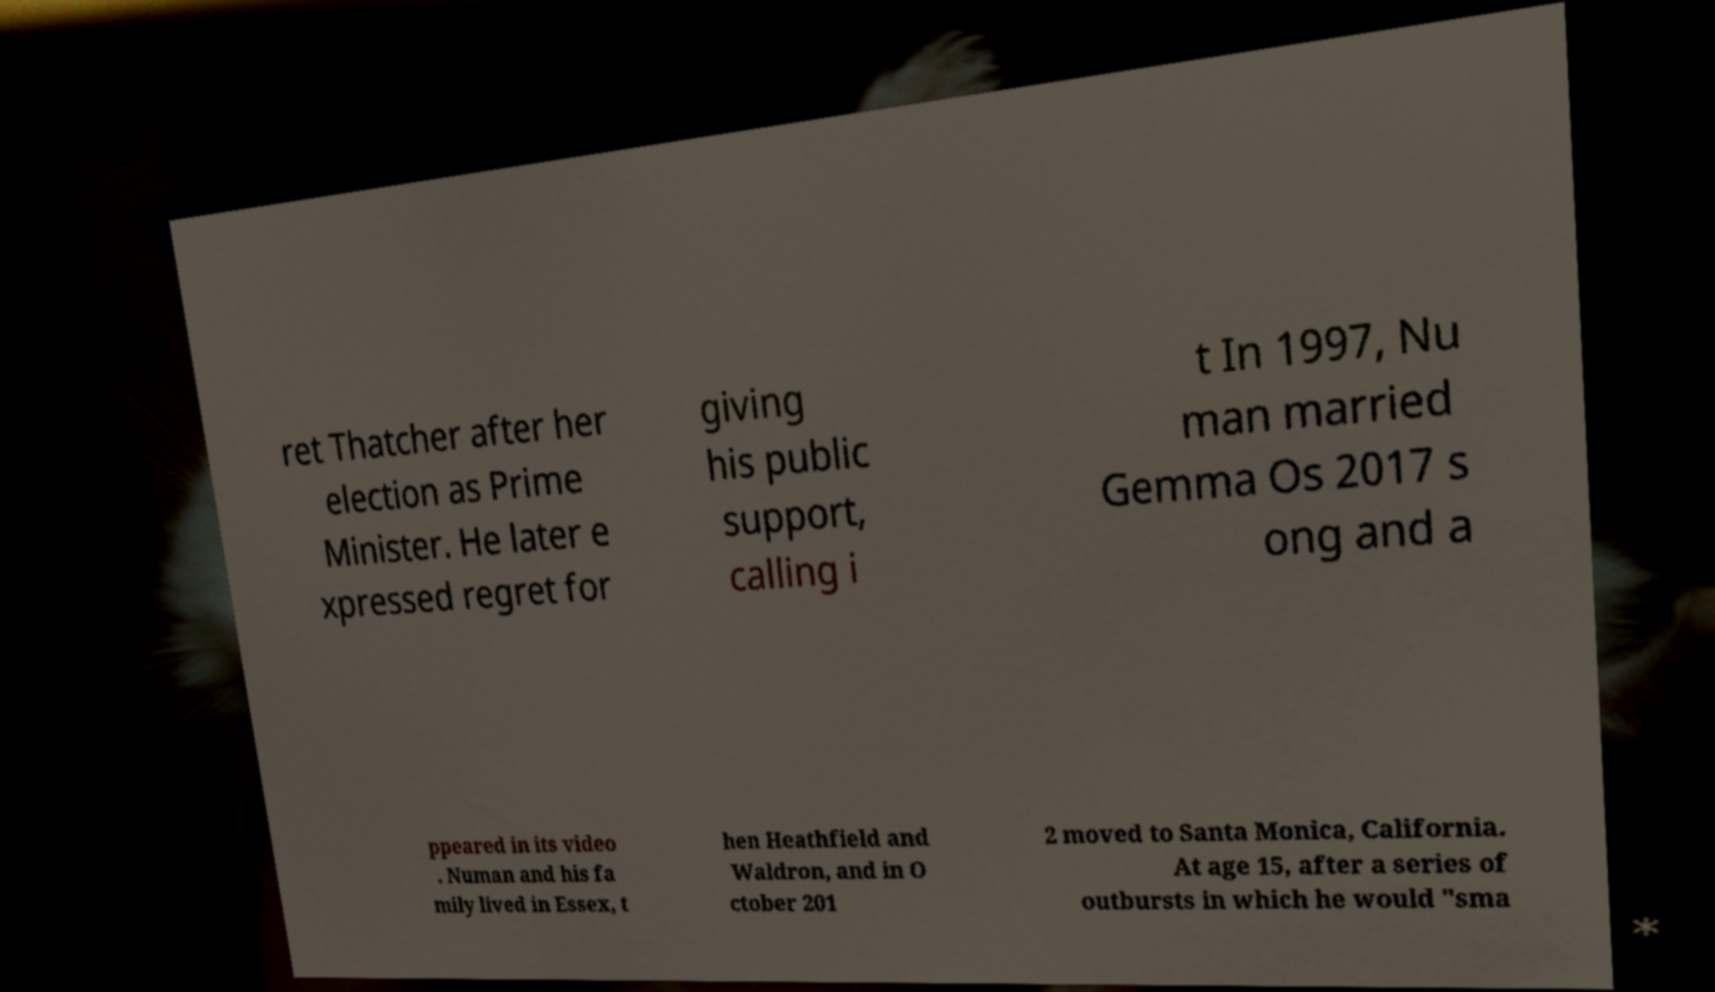For documentation purposes, I need the text within this image transcribed. Could you provide that? ret Thatcher after her election as Prime Minister. He later e xpressed regret for giving his public support, calling i t In 1997, Nu man married Gemma Os 2017 s ong and a ppeared in its video . Numan and his fa mily lived in Essex, t hen Heathfield and Waldron, and in O ctober 201 2 moved to Santa Monica, California. At age 15, after a series of outbursts in which he would "sma 